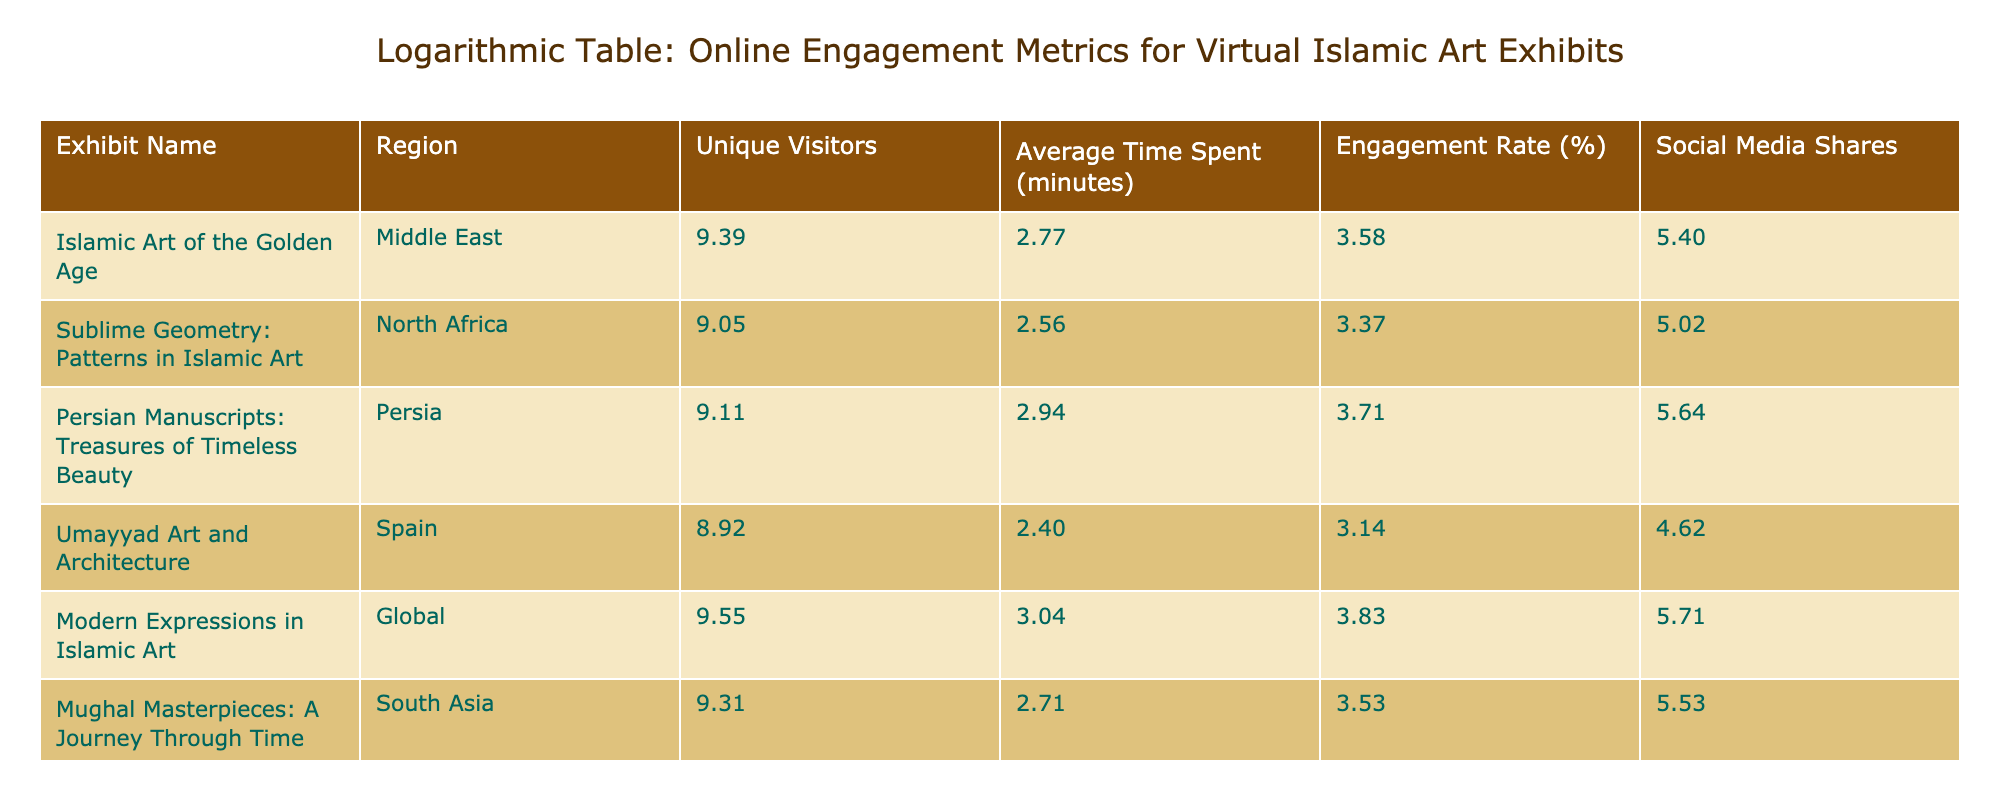What is the engagement rate of the exhibit "Islamic Art of the Golden Age"? The engagement rate for "Islamic Art of the Golden Age," according to the table, is given directly under the Engagement Rate (%) column, which shows 35%.
Answer: 35% Which exhibit has the highest number of unique visitors? Upon reviewing the Unique Visitors column for all exhibits, "Modern Expressions in Islamic Art" has the highest value at 14,000.
Answer: 14,000 What is the average time spent across all exhibits? To find the average time spent, we sum the average time values: 15 + 12 + 18 + 10 + 20 + 14 + 16 + 11 = 126 minutes. Dividing this total by the number of exhibits (8), we get an average of 126 / 8 = 15.75 minutes.
Answer: 15.75 minutes Is the engagement rate for "Persian Manuscripts: Treasures of Timeless Beauty" higher than 35%? The table indicates that the engagement rate for the "Persian Manuscripts" exhibit is 40%, which is indeed higher than 35%.
Answer: Yes What is the difference in social media shares between "Sublime Geometry: Patterns in Islamic Art" and "Islamic Textiles: A Woven Heritage"? The number of social media shares for "Sublime Geometry" is 150, while for "Islamic Textiles" it is 80. To find the difference, we subtract: 150 - 80 = 70 shares.
Answer: 70 shares Which region has the exhibit with the lowest engagement rate? Reviewing the Engagement Rate (%) column, the lowest engagement rate is for "Umayyad Art and Architecture" from Spain, displaying an engagement rate of 22%.
Answer: Spain What is the total number of unique visitors for all exhibits from the Middle East? The unique visitors for exhibits from the Middle East are "Islamic Art of the Golden Age" with 12,000 and "Calligraphy: The Art of Beautiful Writing" with 9,500. Summing these gives us 12,000 + 9,500 = 21,500 unique visitors from the Middle East.
Answer: 21,500 How many exhibits have an engagement rate of at least 30%? Evaluating the Engagement Rate (%) column, the exhibits meeting this criterion are "Islamic Art of the Golden Age" (35%), "Persian Manuscripts" (40%), "Modern Expressions" (45%), "Mughal Masterpieces" (33%), and "Calligraphy" (30%). This makes a total of 5 exhibits with an engagement rate of at least 30%.
Answer: 5 exhibits 